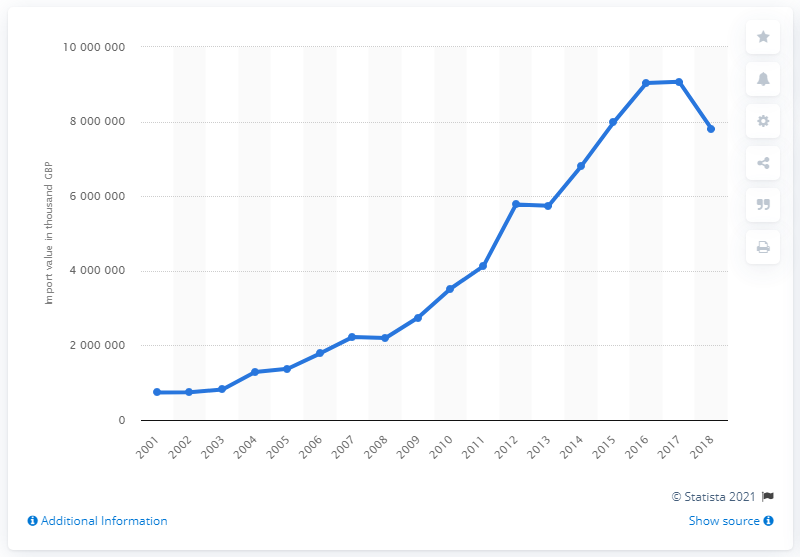Outline some significant characteristics in this image. In 2001, the importation of human and animal blood was recorded in the United Kingdom. 